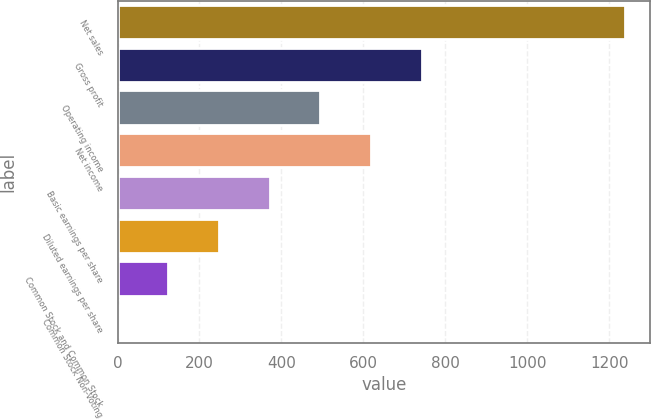<chart> <loc_0><loc_0><loc_500><loc_500><bar_chart><fcel>Net sales<fcel>Gross profit<fcel>Operating income<fcel>Net income<fcel>Basic earnings per share<fcel>Diluted earnings per share<fcel>Common Stock and Common Stock<fcel>Common Stock Non-Voting<nl><fcel>1237.1<fcel>742.43<fcel>495.11<fcel>618.77<fcel>371.45<fcel>247.79<fcel>124.13<fcel>0.47<nl></chart> 